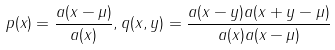Convert formula to latex. <formula><loc_0><loc_0><loc_500><loc_500>p ( x ) = \frac { a ( x - \mu ) } { a ( x ) } , q ( x , y ) = \frac { a ( x - y ) a ( x + y - \mu ) } { a ( x ) a ( x - \mu ) }</formula> 